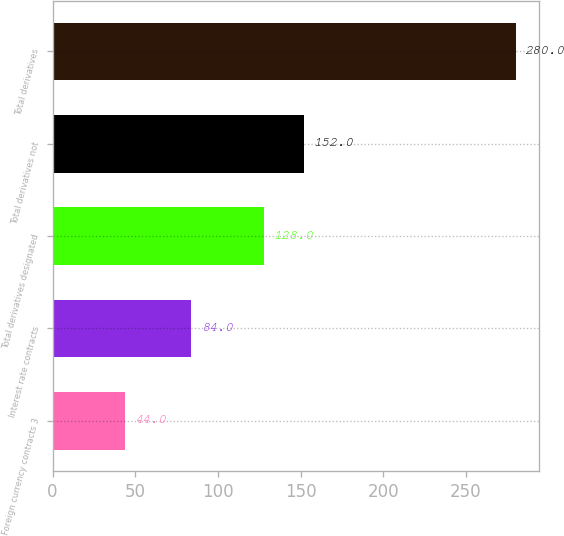Convert chart to OTSL. <chart><loc_0><loc_0><loc_500><loc_500><bar_chart><fcel>Foreign currency contracts 3<fcel>Interest rate contracts<fcel>Total derivatives designated<fcel>Total derivatives not<fcel>Total derivatives<nl><fcel>44<fcel>84<fcel>128<fcel>152<fcel>280<nl></chart> 